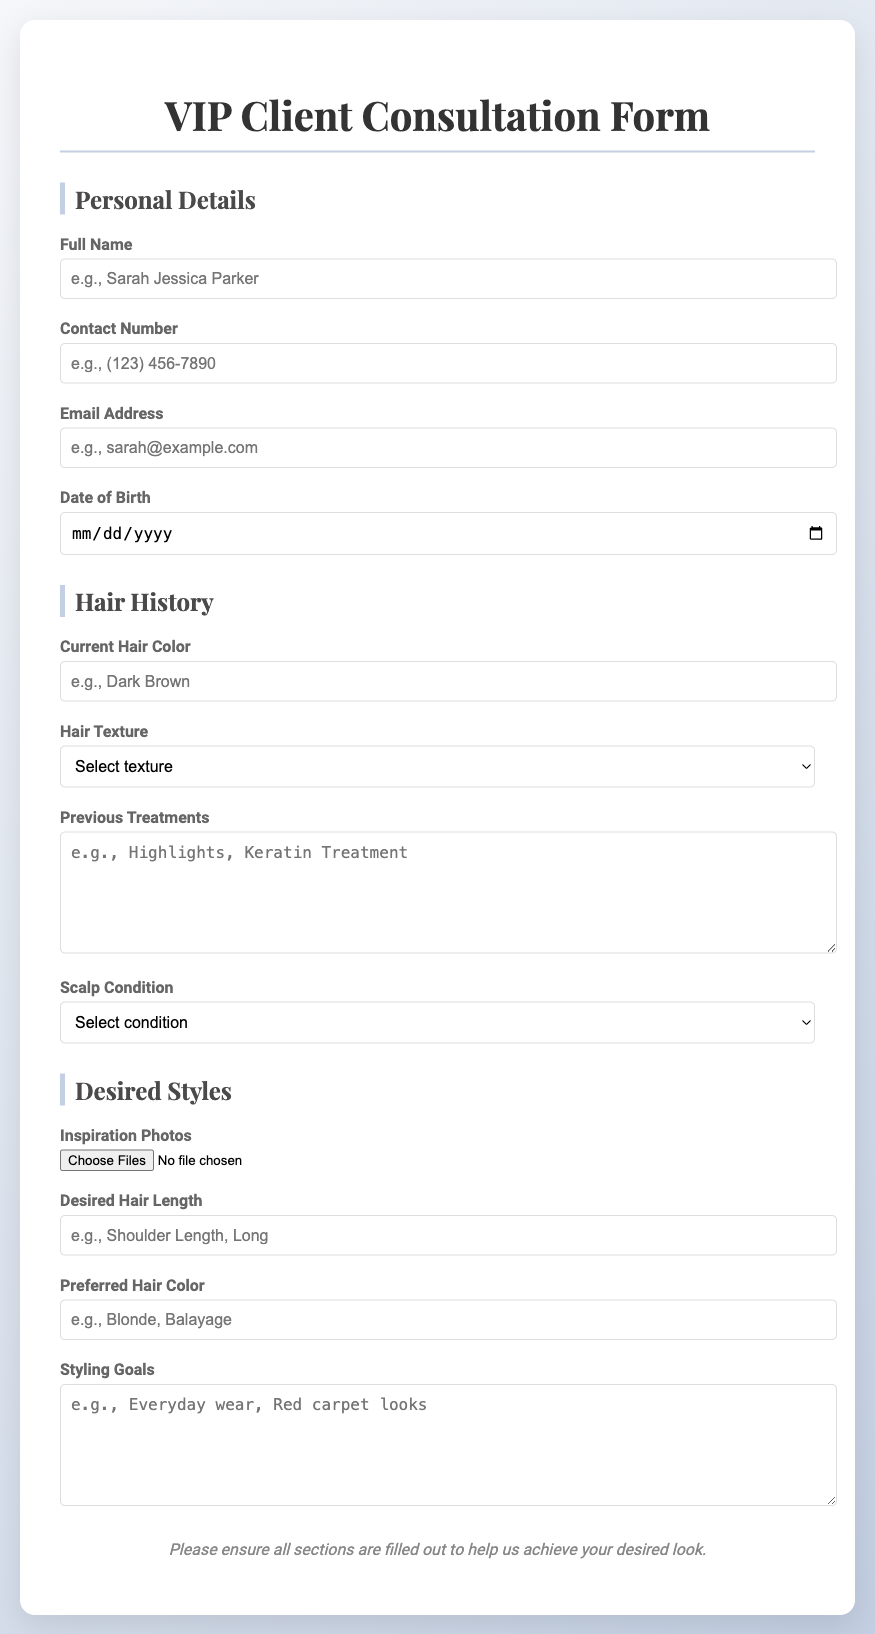What is the title of the form? The title is prominently displayed at the top of the document, indicating the form's purpose for VIP clients.
Answer: VIP Client Consultation Form What details are required in the Personal Details section? This section includes fields for full name, contact number, email address, and date of birth, indicating the information needed about the client.
Answer: Full Name, Contact Number, Email Address, Date of Birth What options are available for Hair Texture? The document lists specific options for hair texture, showcasing the type of hair the client may have.
Answer: Straight, Wavy, Curly, Coily What is the placeholder example for the Desired Hair Length? The placeholder gives an example of the types of lengths that could be specified by the client, demonstrating clear expectations.
Answer: Shoulder Length Which condition can be selected for the Scalp Condition? The options available showcase the various conditions the client's scalp may have, assisting in proper treatment.
Answer: Normal, Dry, Oily, Sensitive What is the purpose of the Inspiration Photos field? This field allows clients to upload images that reflect their desired style, indicating personalized styling.
Answer: Upload photos that reflect desired styles What does the notes section emphasize? The notes serve as a reminder to clients about the importance of filling out all sections fully to achieve their look.
Answer: Ensure all sections are filled out What type of file can be uploaded for Inspiration Photos? The upload field specifies the type of files that the client is allowed to submit, which aids in gathering visual references.
Answer: Image files What section follows the Hair History section? Understanding the flow of the document indicates what information is gathered after hair history.
Answer: Desired Styles 